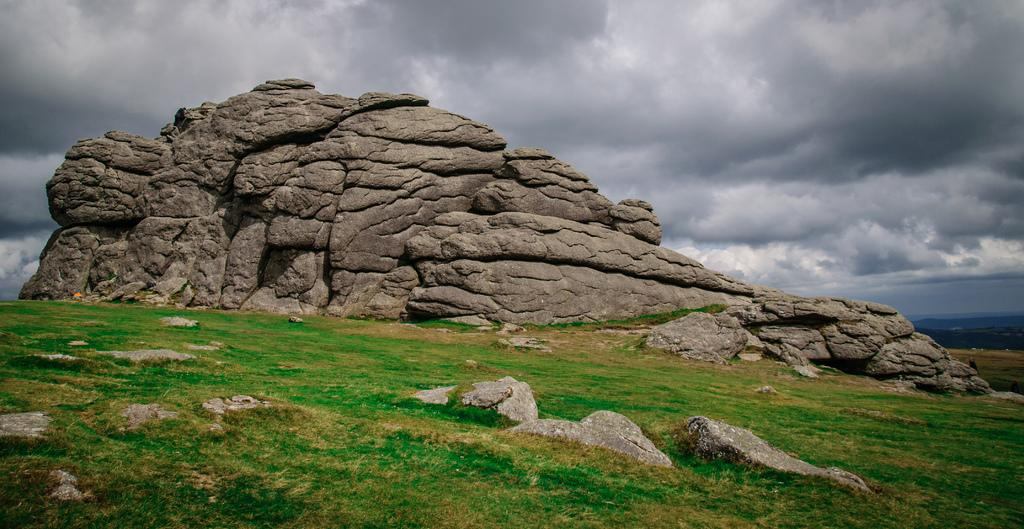What type of terrain is visible in the image? There is grass and rocks visible in the image. What geographical feature can be seen in the background of the image? There are mountains in the image. What is visible in the sky in the image? The sky is visible in the image. Based on the lighting and shadows, when do you think the image was taken? The image was likely taken during the day. What type of dirt is visible on the guide's shoes in the image? There is no guide or shoes present in the image. Can you describe the branch that the bird is perched on in the image? There is no bird or branch present in the image. 